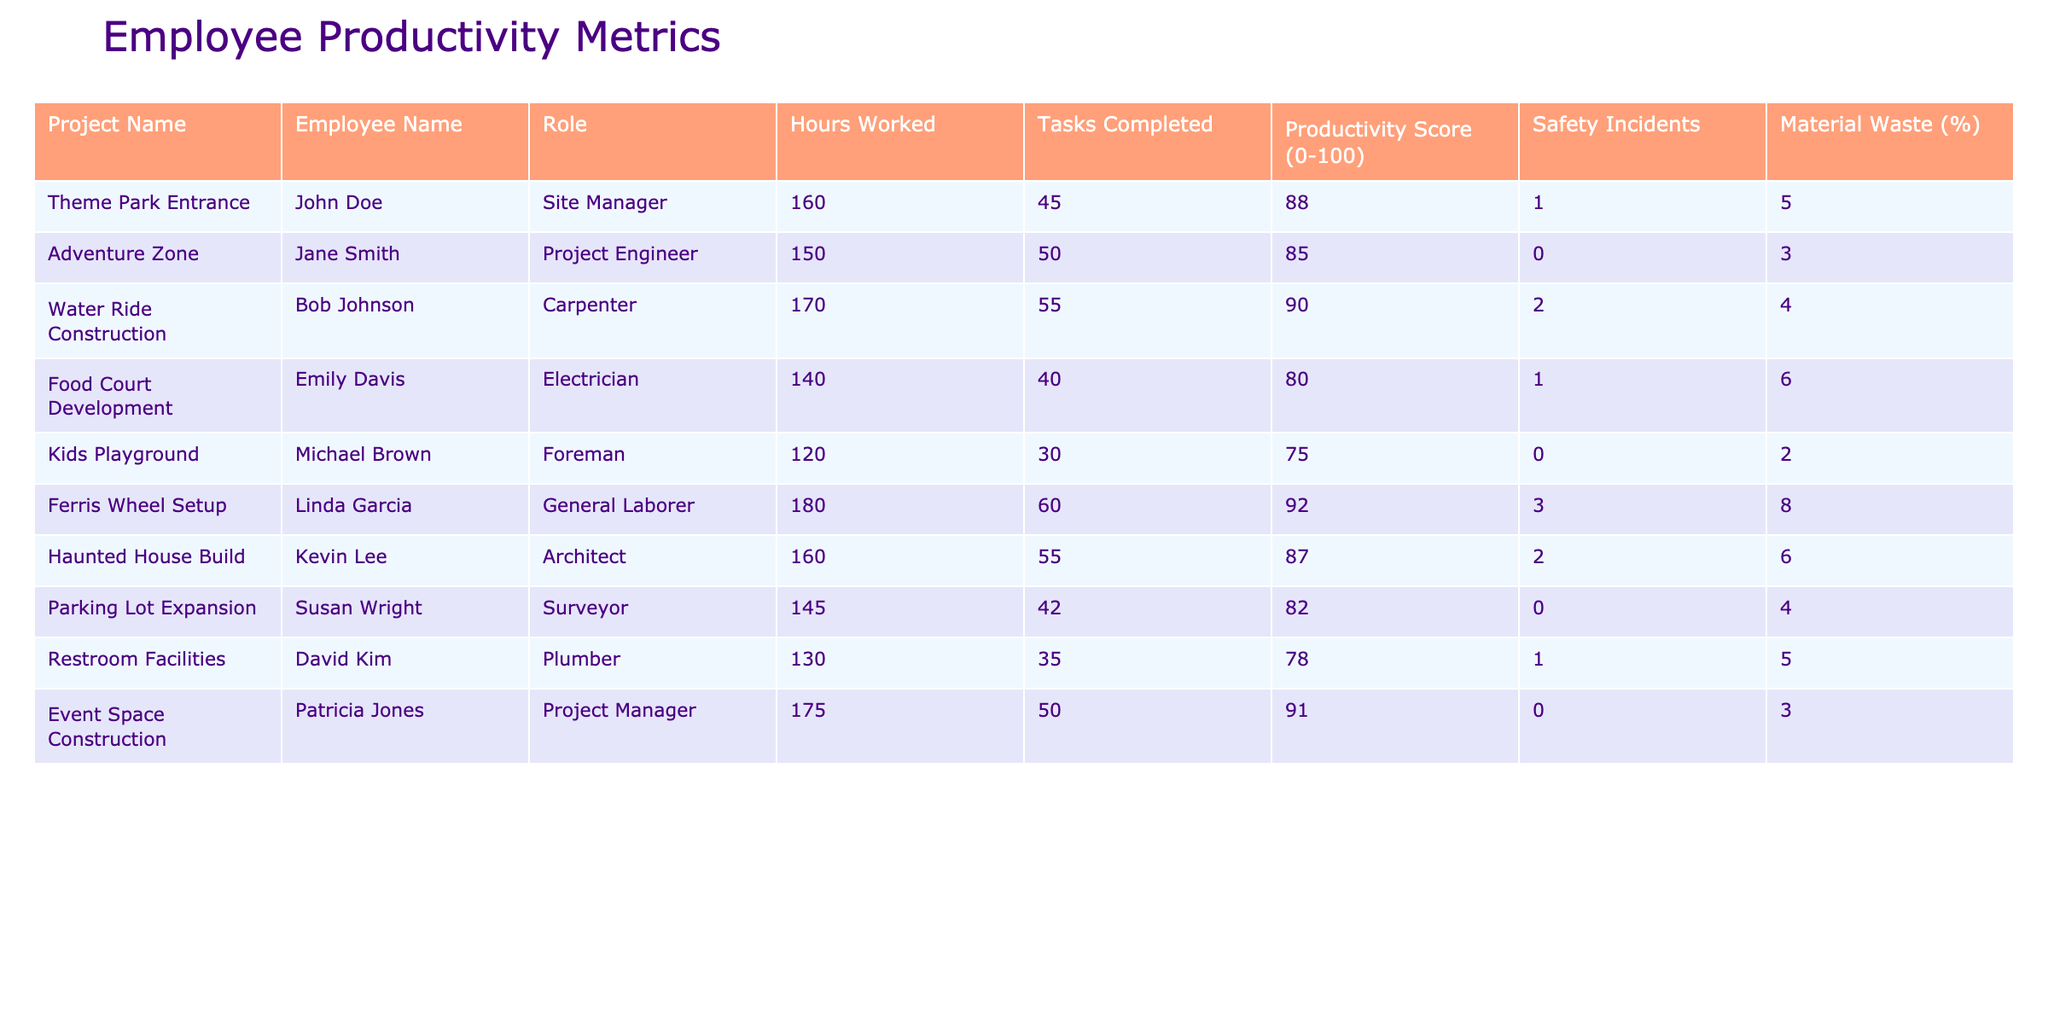What is the productivity score of Bob Johnson? From the table, the row corresponding to Bob Johnson shows a productivity score of 90.
Answer: 90 Which project had the highest number of tasks completed? By reviewing the table, Linda Garcia on the Ferris Wheel Setup completed the most tasks at 60.
Answer: 60 What is the average productivity score for all employees? The productivity scores are 88, 85, 90, 80, 75, 92, 87, 82, 78, and 91. Adding these gives 888, and dividing by 10 (the number of employees) results in an average of 88.8.
Answer: 88.8 Did any employee have zero safety incidents? Looking at the safety incidents column, both Jane Smith and Susan Wright have zero safety incidents recorded.
Answer: Yes Which project had the lowest material waste percentage? Checking the material waste percentage in the table, the Kids Playground project by Michael Brown shows the lowest at 2%.
Answer: 2% How many hours did Emily Davis work compared to Linda Garcia? Emily Davis worked 140 hours, while Linda Garcia worked 180 hours. The difference is 180 - 140 = 40.
Answer: 40 What is the productivity score difference between the project with the highest score and the lowest score? The highest productivity score is 92 for Linda Garcia (Ferris Wheel Setup) and the lowest is 75 for Michael Brown (Kids Playground). The difference is 92 - 75 = 17.
Answer: 17 Is the average hours worked across all projects greater than 150? Summing the hours worked (160 + 150 + 170 + 140 + 120 + 180 + 160 + 145 + 130 + 175) gives 1,600. Dividing by 10 gives an average of 160, which is greater than 150.
Answer: Yes Which role had the most safety incidents, and how many incidents were there? The row for Linda Garcia shows 3 safety incidents, which is the highest among the roles in the table.
Answer: 3 